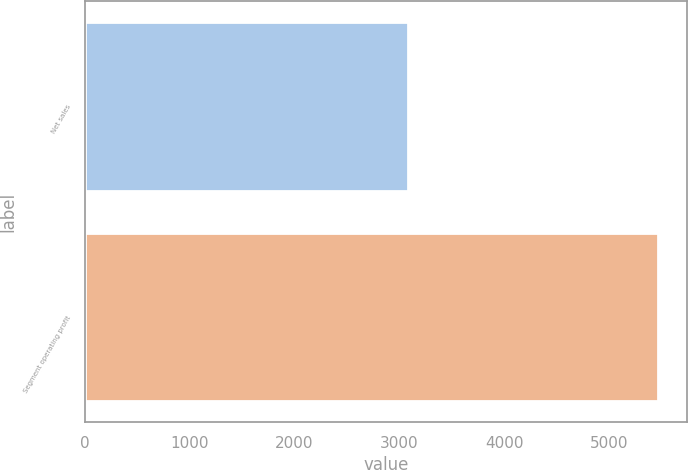Convert chart to OTSL. <chart><loc_0><loc_0><loc_500><loc_500><bar_chart><fcel>Net sales<fcel>Segment operating profit<nl><fcel>3081<fcel>5468<nl></chart> 